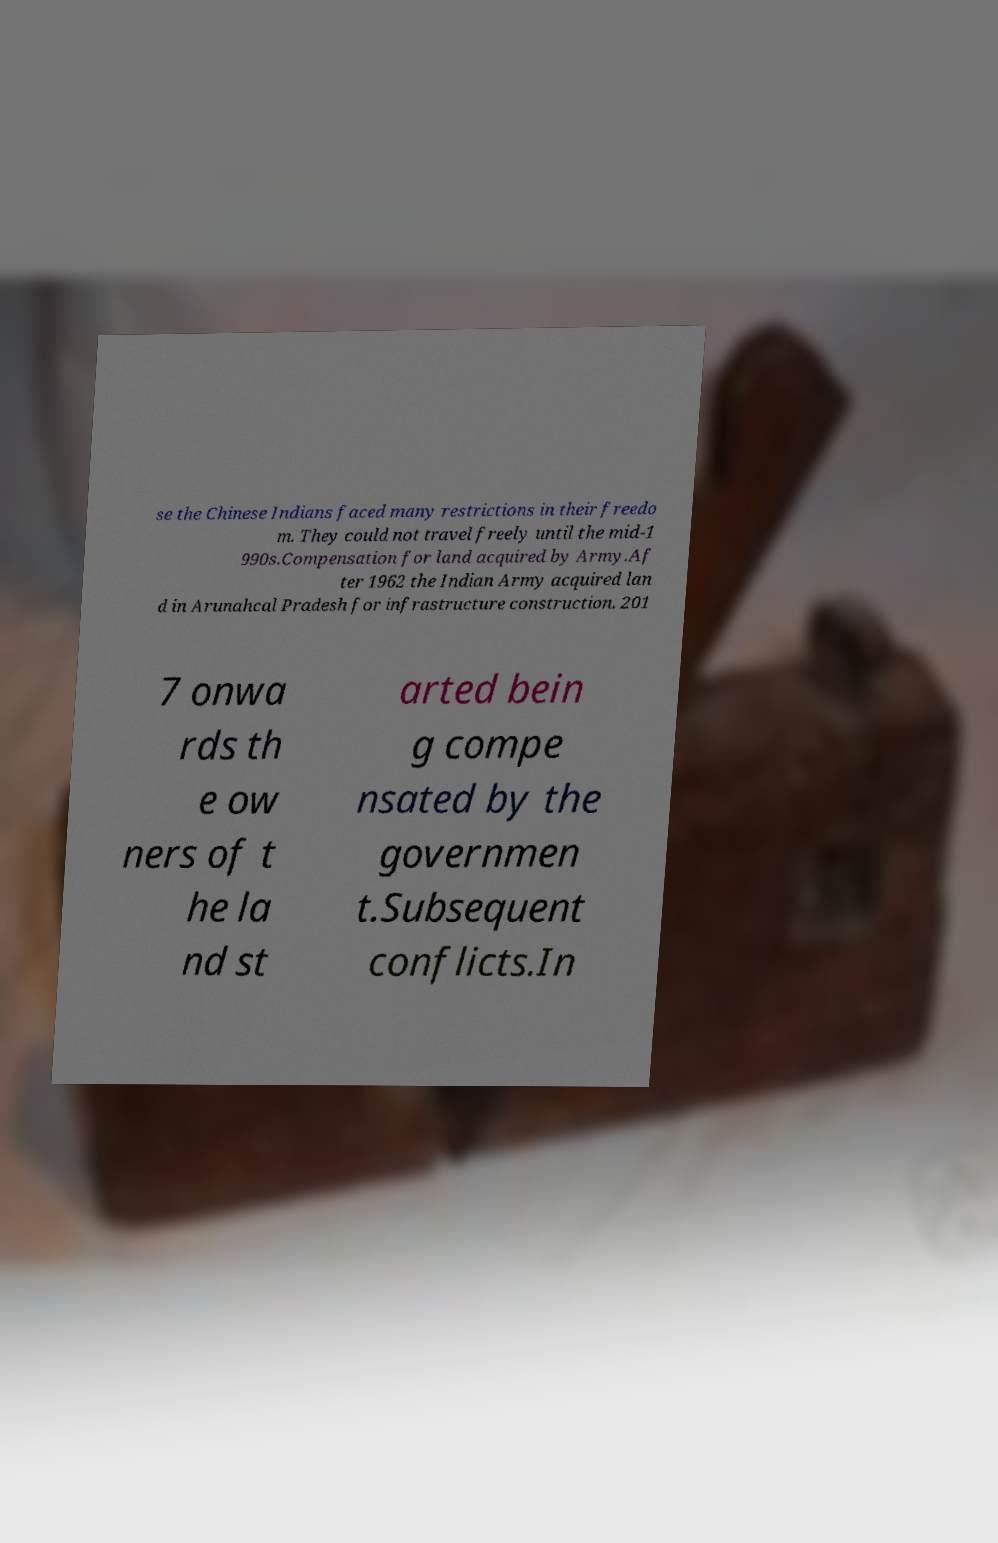What messages or text are displayed in this image? I need them in a readable, typed format. se the Chinese Indians faced many restrictions in their freedo m. They could not travel freely until the mid-1 990s.Compensation for land acquired by Army.Af ter 1962 the Indian Army acquired lan d in Arunahcal Pradesh for infrastructure construction. 201 7 onwa rds th e ow ners of t he la nd st arted bein g compe nsated by the governmen t.Subsequent conflicts.In 